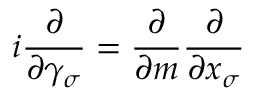<formula> <loc_0><loc_0><loc_500><loc_500>i \frac { \partial } { \partial \gamma _ { \sigma } } = \frac { \partial } { \partial m } \frac { \partial } { \partial x _ { \sigma } }</formula> 